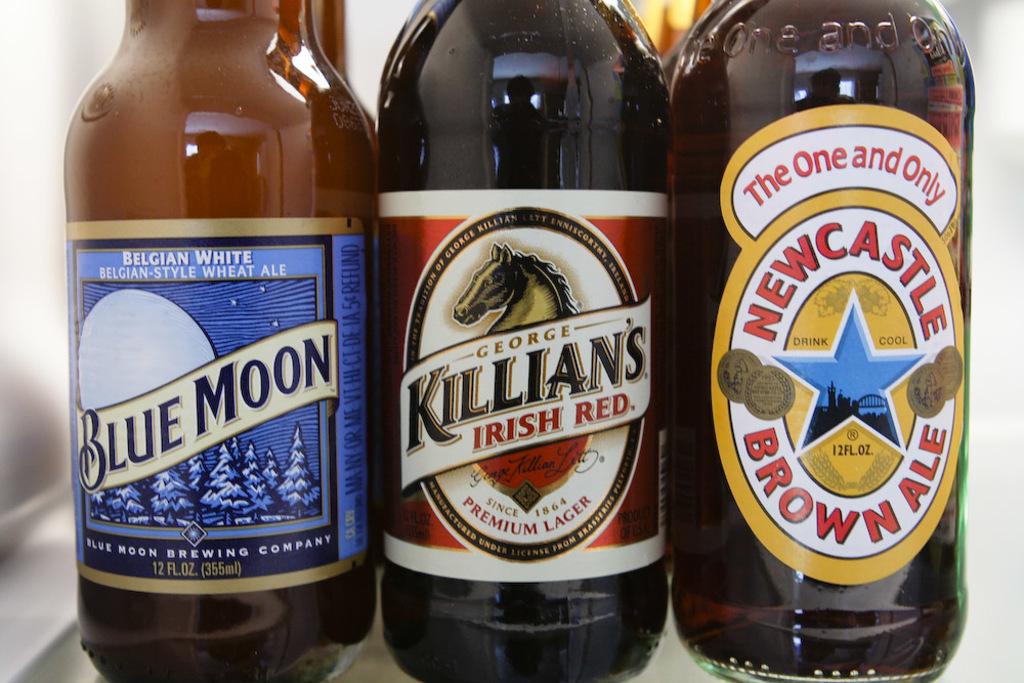What kind of ale is blue moon?
Offer a very short reply. Belgian-style wheat ale. Which brand is brown ale?
Keep it short and to the point. Newcastle. 